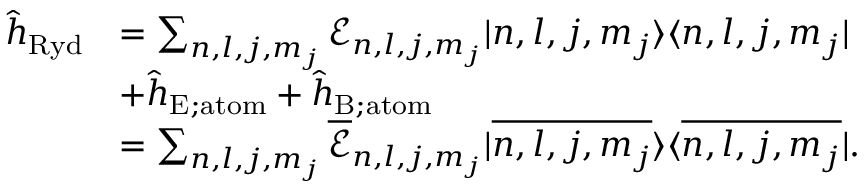<formula> <loc_0><loc_0><loc_500><loc_500>\begin{array} { r l } { \hat { h } _ { R y d } } & { = \sum _ { n , l , j , m _ { j } } \mathcal { E } _ { n , l , j , m _ { j } } | n , l , j , m _ { j } \rangle \langle n , l , j , m _ { j } | } \\ & { + \hat { h } _ { E ; a t o m } + \hat { h } _ { B ; a t o m } } \\ & { = \sum _ { n , l , j , m _ { j } } \overline { { \mathcal { E } } } _ { n , l , j , m _ { j } } | \overline { { n , l , j , m _ { j } } } \rangle \langle \overline { { n , l , j , m _ { j } } } | . } \end{array}</formula> 